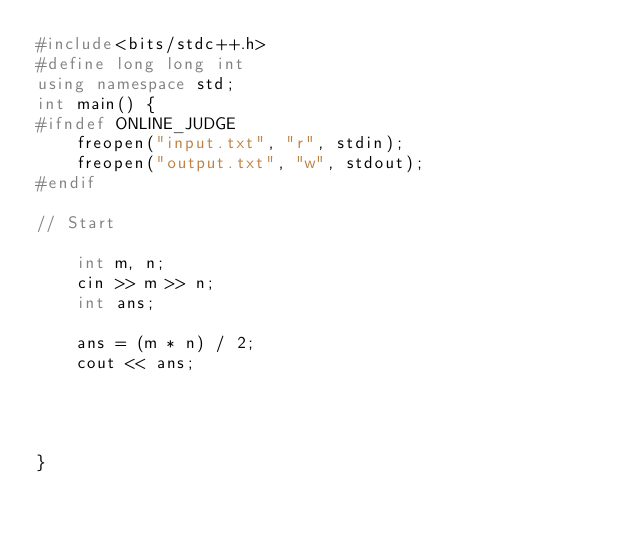<code> <loc_0><loc_0><loc_500><loc_500><_C++_>#include<bits/stdc++.h>
#define long long int
using namespace std;
int main() {
#ifndef ONLINE_JUDGE
	freopen("input.txt", "r", stdin);
	freopen("output.txt", "w", stdout);
#endif

// Start

	int m, n;
	cin >> m >> n;
	int ans;

	ans = (m * n) / 2;
	cout << ans;




}</code> 